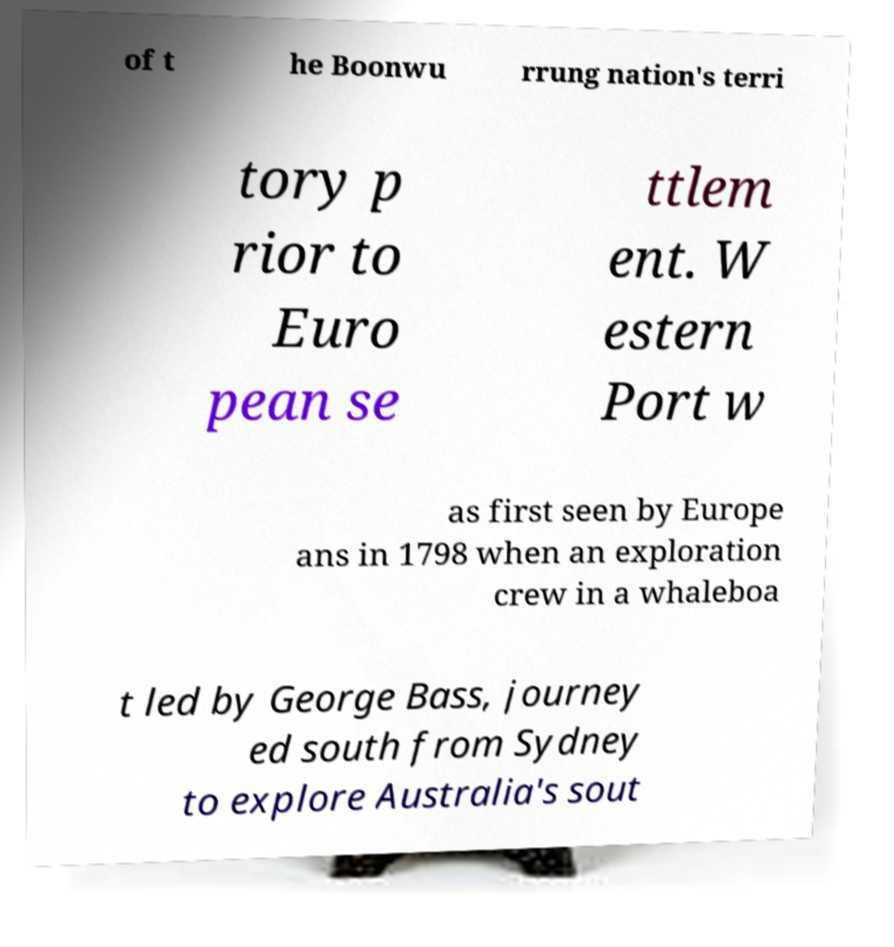Please read and relay the text visible in this image. What does it say? of t he Boonwu rrung nation's terri tory p rior to Euro pean se ttlem ent. W estern Port w as first seen by Europe ans in 1798 when an exploration crew in a whaleboa t led by George Bass, journey ed south from Sydney to explore Australia's sout 